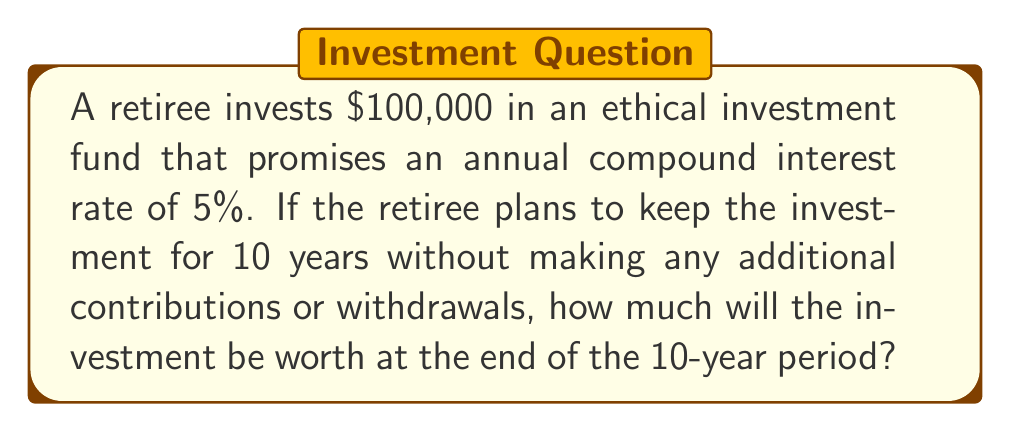Could you help me with this problem? To solve this problem, we'll use the compound interest formula:

$$A = P(1 + r)^n$$

Where:
$A$ = Final amount
$P$ = Principal (initial investment)
$r$ = Annual interest rate (as a decimal)
$n$ = Number of years

Given:
$P = \$100,000$
$r = 5\% = 0.05$
$n = 10$ years

Let's substitute these values into the formula:

$$A = 100,000(1 + 0.05)^{10}$$

Now, let's calculate step-by-step:

1) First, calculate $(1 + 0.05)^{10}$:
   $$(1.05)^{10} = 1.6288946...$$

2) Multiply this result by the principal:
   $$100,000 \times 1.6288946... = 162,889.46...$$

3) Round to the nearest cent:
   $$162,889.46$$

Therefore, after 10 years, the ethical investment will be worth $162,889.46.
Answer: $162,889.46 